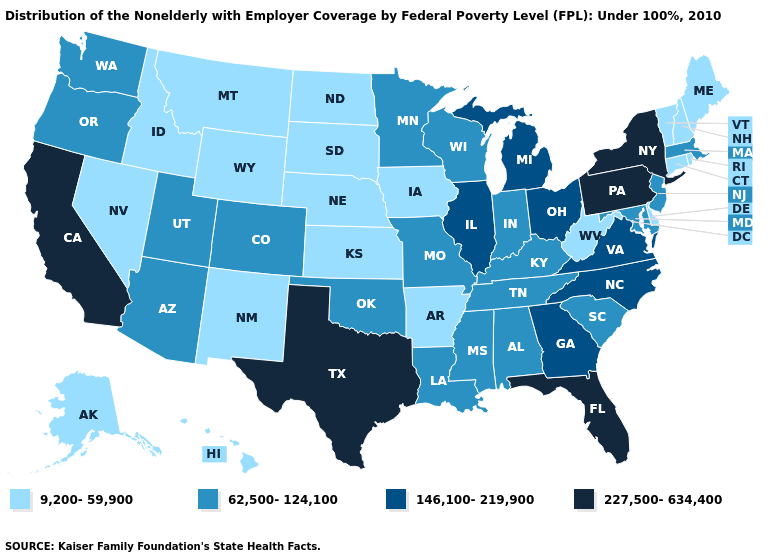Among the states that border Minnesota , does Iowa have the lowest value?
Answer briefly. Yes. Name the states that have a value in the range 146,100-219,900?
Quick response, please. Georgia, Illinois, Michigan, North Carolina, Ohio, Virginia. What is the lowest value in the South?
Answer briefly. 9,200-59,900. Among the states that border South Dakota , does Wyoming have the highest value?
Concise answer only. No. Among the states that border Wisconsin , which have the highest value?
Be succinct. Illinois, Michigan. Does the map have missing data?
Quick response, please. No. Which states have the lowest value in the Northeast?
Concise answer only. Connecticut, Maine, New Hampshire, Rhode Island, Vermont. How many symbols are there in the legend?
Give a very brief answer. 4. Does Arizona have the lowest value in the West?
Concise answer only. No. Name the states that have a value in the range 9,200-59,900?
Quick response, please. Alaska, Arkansas, Connecticut, Delaware, Hawaii, Idaho, Iowa, Kansas, Maine, Montana, Nebraska, Nevada, New Hampshire, New Mexico, North Dakota, Rhode Island, South Dakota, Vermont, West Virginia, Wyoming. What is the highest value in states that border Tennessee?
Keep it brief. 146,100-219,900. Is the legend a continuous bar?
Be succinct. No. Name the states that have a value in the range 227,500-634,400?
Keep it brief. California, Florida, New York, Pennsylvania, Texas. Does Mississippi have the lowest value in the South?
Concise answer only. No. What is the highest value in the USA?
Quick response, please. 227,500-634,400. 